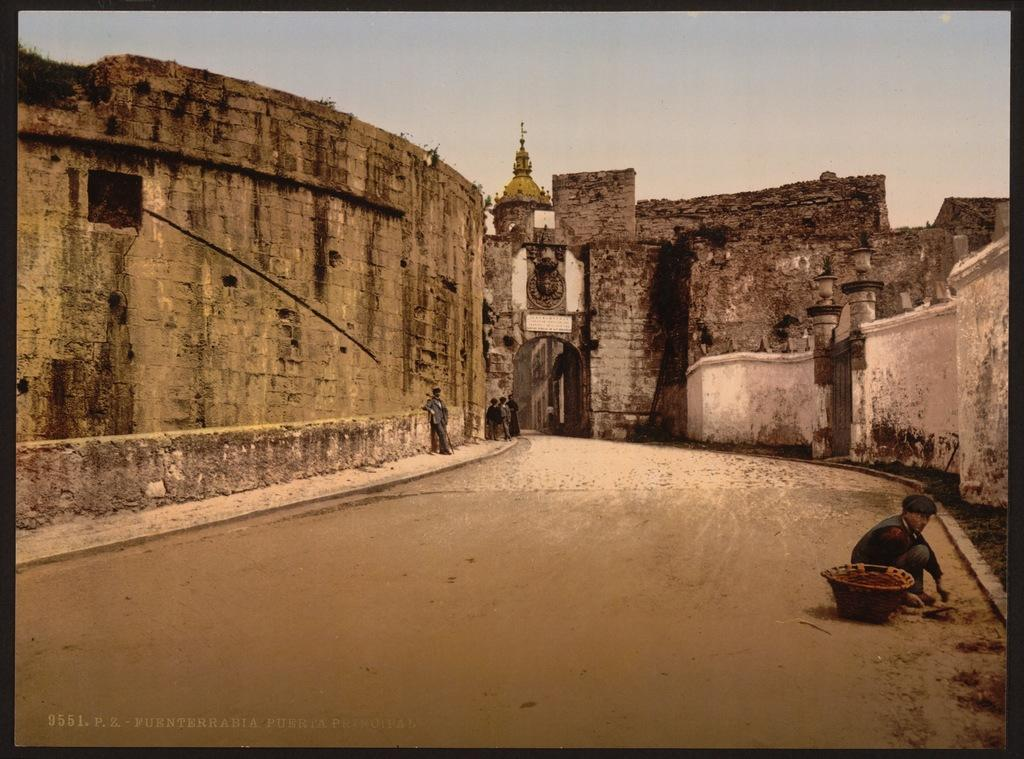What type of image is being described? The image is an edited picture. What is the main subject of the image? There is a fort in the image. Are there any people present in the image? Yes, there are people in the image. What can be seen in the background of the image? The sky is visible in the background of the image. Is there any additional information or branding on the image? Yes, there is a watermark on the image. What type of copper game is being played by the pigs in the image? There are no pigs or copper games present in the image. 